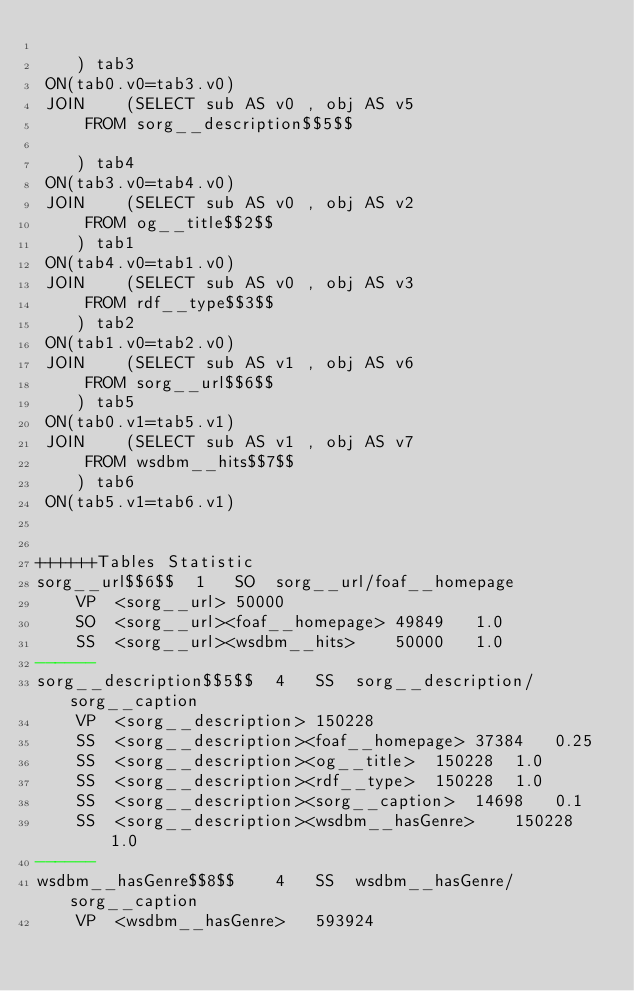<code> <loc_0><loc_0><loc_500><loc_500><_SQL_>	
	) tab3
 ON(tab0.v0=tab3.v0)
 JOIN    (SELECT sub AS v0 , obj AS v5 
	 FROM sorg__description$$5$$
	
	) tab4
 ON(tab3.v0=tab4.v0)
 JOIN    (SELECT sub AS v0 , obj AS v2 
	 FROM og__title$$2$$
	) tab1
 ON(tab4.v0=tab1.v0)
 JOIN    (SELECT sub AS v0 , obj AS v3 
	 FROM rdf__type$$3$$
	) tab2
 ON(tab1.v0=tab2.v0)
 JOIN    (SELECT sub AS v1 , obj AS v6 
	 FROM sorg__url$$6$$
	) tab5
 ON(tab0.v1=tab5.v1)
 JOIN    (SELECT sub AS v1 , obj AS v7 
	 FROM wsdbm__hits$$7$$
	) tab6
 ON(tab5.v1=tab6.v1)


++++++Tables Statistic
sorg__url$$6$$	1	SO	sorg__url/foaf__homepage
	VP	<sorg__url>	50000
	SO	<sorg__url><foaf__homepage>	49849	1.0
	SS	<sorg__url><wsdbm__hits>	50000	1.0
------
sorg__description$$5$$	4	SS	sorg__description/sorg__caption
	VP	<sorg__description>	150228
	SS	<sorg__description><foaf__homepage>	37384	0.25
	SS	<sorg__description><og__title>	150228	1.0
	SS	<sorg__description><rdf__type>	150228	1.0
	SS	<sorg__description><sorg__caption>	14698	0.1
	SS	<sorg__description><wsdbm__hasGenre>	150228	1.0
------
wsdbm__hasGenre$$8$$	4	SS	wsdbm__hasGenre/sorg__caption
	VP	<wsdbm__hasGenre>	593924</code> 